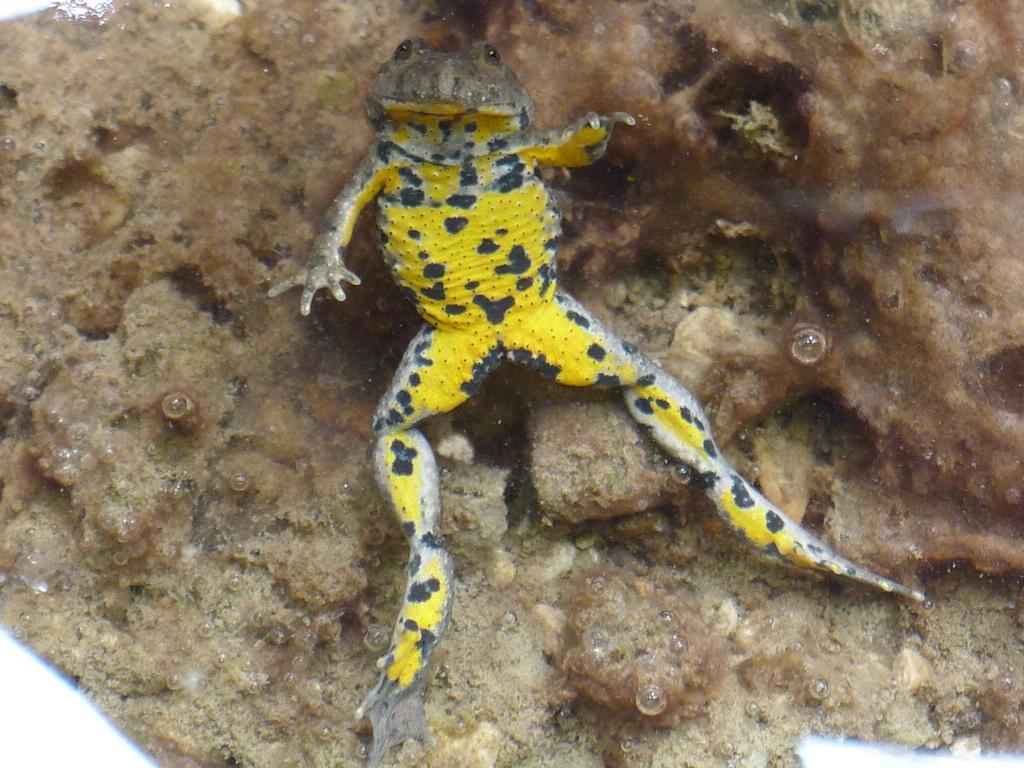What is the main subject of the picture? The main subject of the picture is a frog. Can you describe the appearance of the frog? The frog is in yellow and black color. What type of environment can be seen in the background of the picture? There is land visible in the background of the picture. What type of stocking is the scarecrow wearing in the image? There is no scarecrow or stocking present in the image; it features a frog in yellow and black color with land visible in the background. 